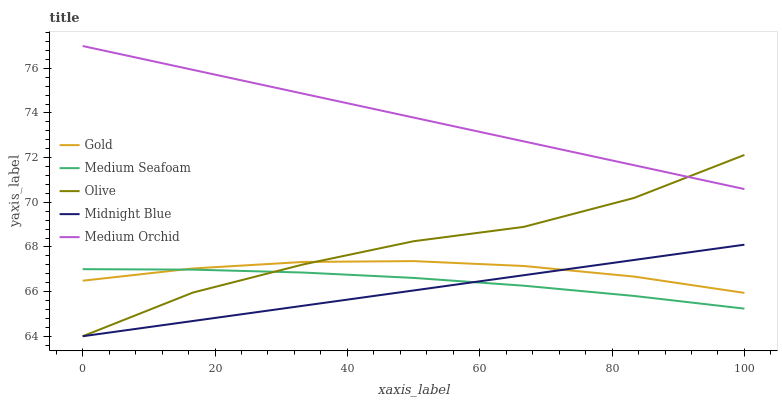Does Medium Seafoam have the minimum area under the curve?
Answer yes or no. No. Does Medium Seafoam have the maximum area under the curve?
Answer yes or no. No. Is Medium Seafoam the smoothest?
Answer yes or no. No. Is Medium Seafoam the roughest?
Answer yes or no. No. Does Medium Seafoam have the lowest value?
Answer yes or no. No. Does Medium Seafoam have the highest value?
Answer yes or no. No. Is Gold less than Medium Orchid?
Answer yes or no. Yes. Is Medium Orchid greater than Gold?
Answer yes or no. Yes. Does Gold intersect Medium Orchid?
Answer yes or no. No. 